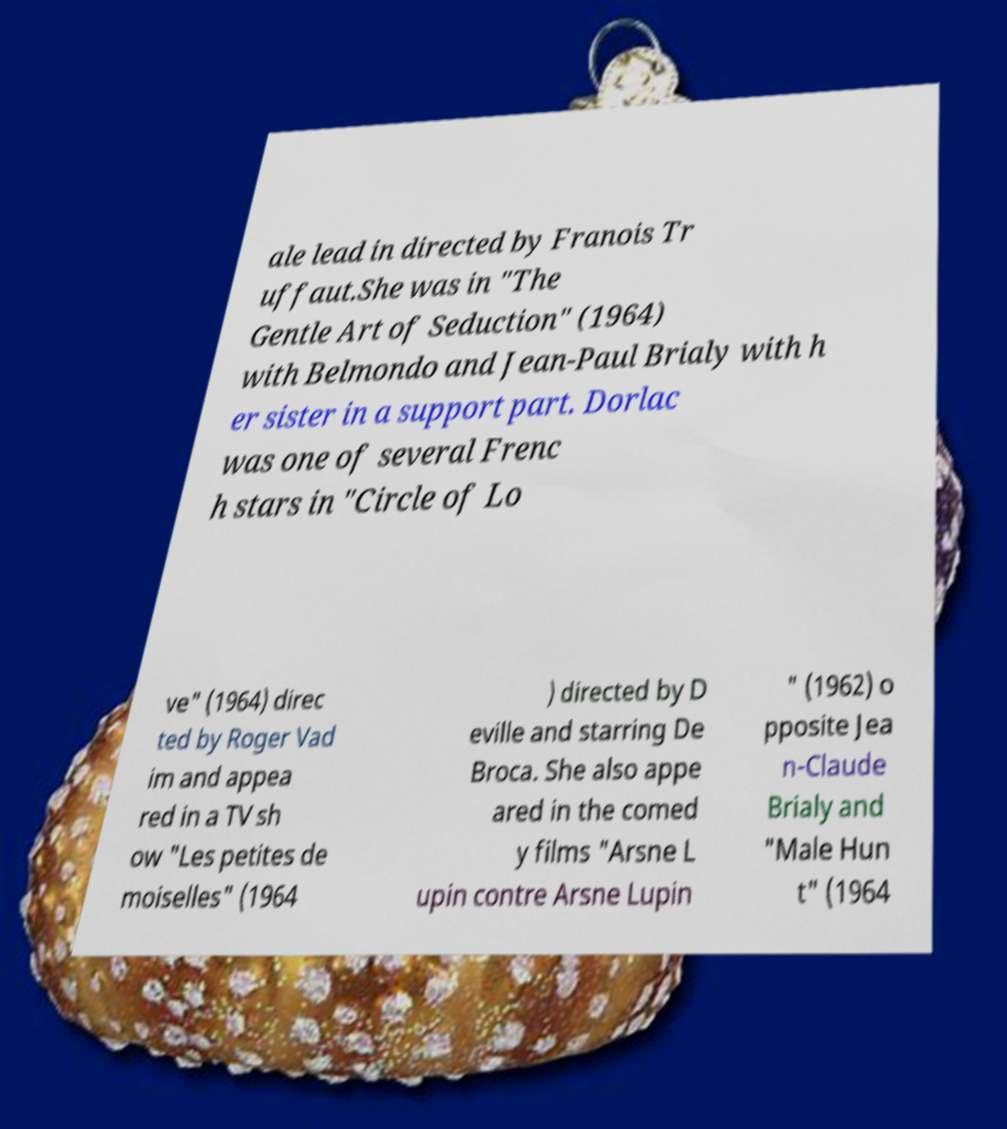Can you accurately transcribe the text from the provided image for me? ale lead in directed by Franois Tr uffaut.She was in "The Gentle Art of Seduction" (1964) with Belmondo and Jean-Paul Brialy with h er sister in a support part. Dorlac was one of several Frenc h stars in "Circle of Lo ve" (1964) direc ted by Roger Vad im and appea red in a TV sh ow "Les petites de moiselles" (1964 ) directed by D eville and starring De Broca. She also appe ared in the comed y films "Arsne L upin contre Arsne Lupin " (1962) o pposite Jea n-Claude Brialy and "Male Hun t" (1964 